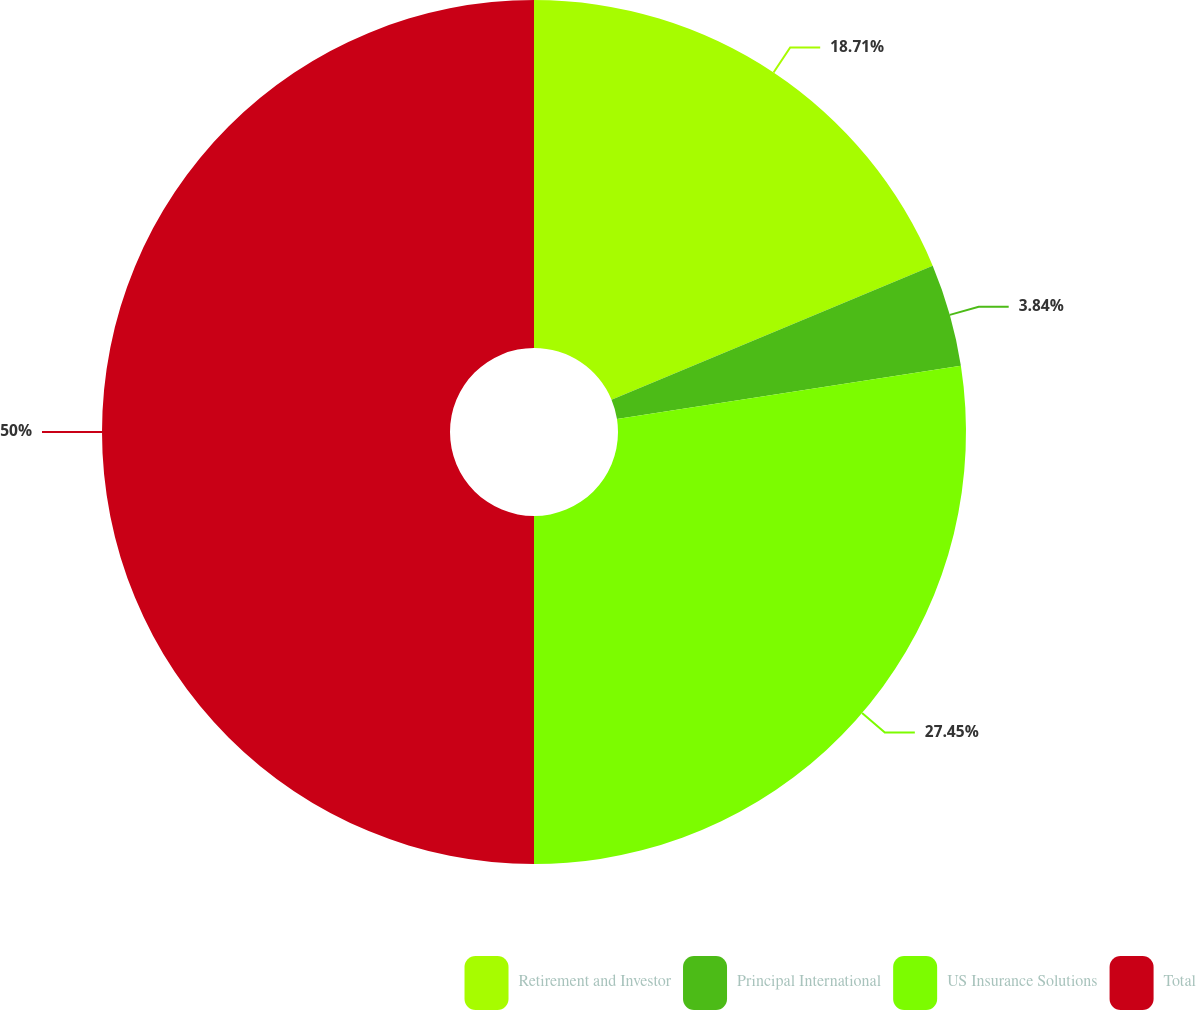<chart> <loc_0><loc_0><loc_500><loc_500><pie_chart><fcel>Retirement and Investor<fcel>Principal International<fcel>US Insurance Solutions<fcel>Total<nl><fcel>18.71%<fcel>3.84%<fcel>27.45%<fcel>50.0%<nl></chart> 